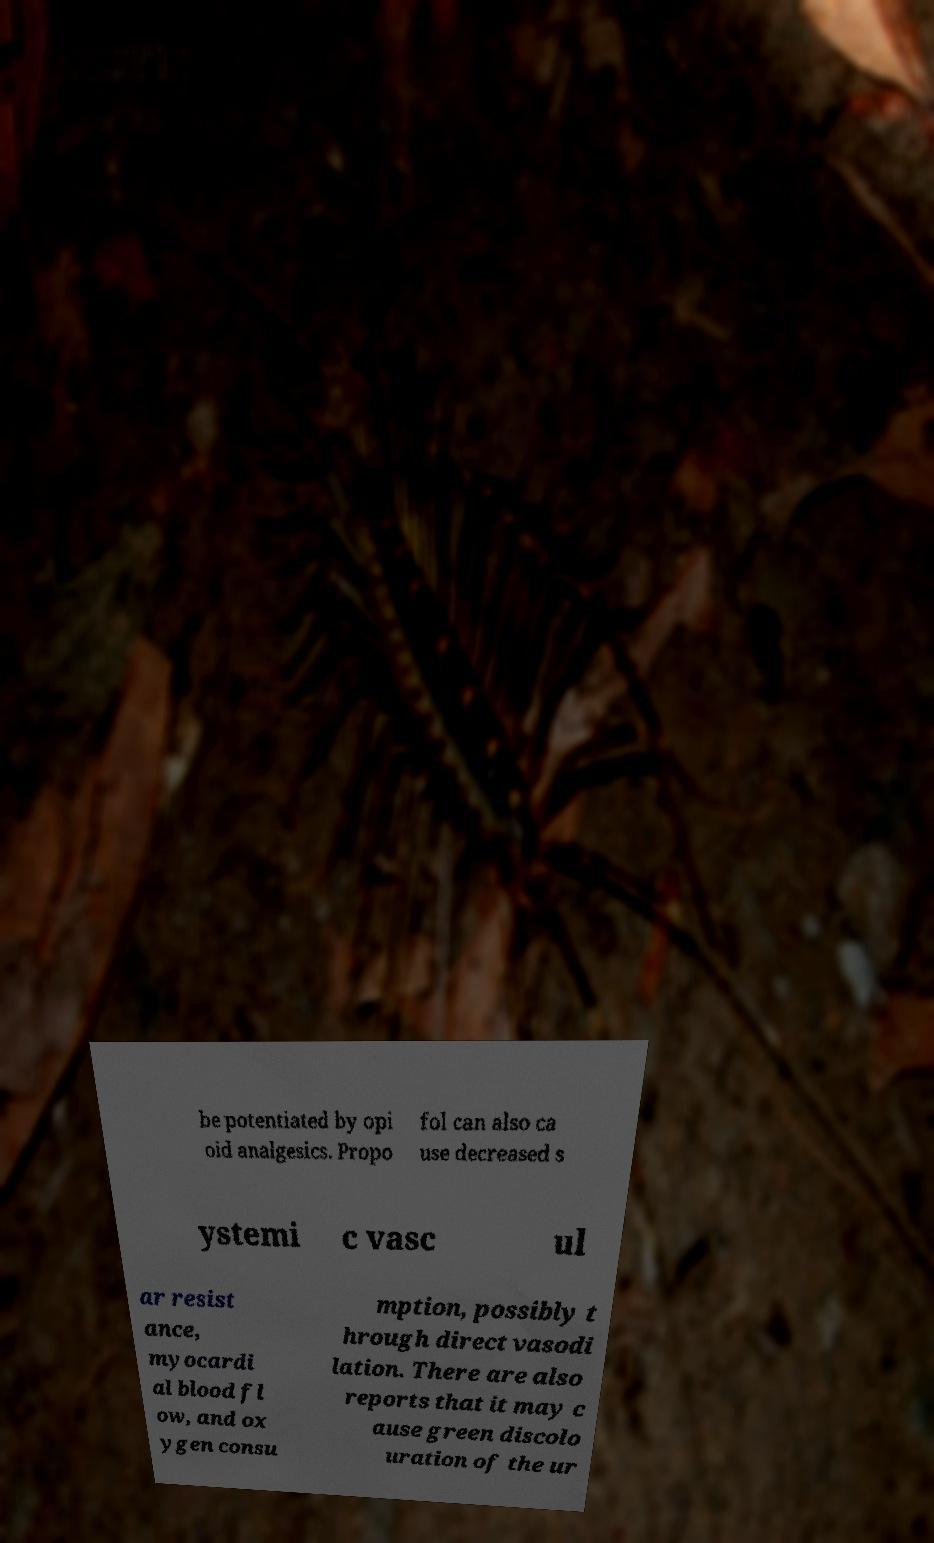Can you accurately transcribe the text from the provided image for me? be potentiated by opi oid analgesics. Propo fol can also ca use decreased s ystemi c vasc ul ar resist ance, myocardi al blood fl ow, and ox ygen consu mption, possibly t hrough direct vasodi lation. There are also reports that it may c ause green discolo uration of the ur 